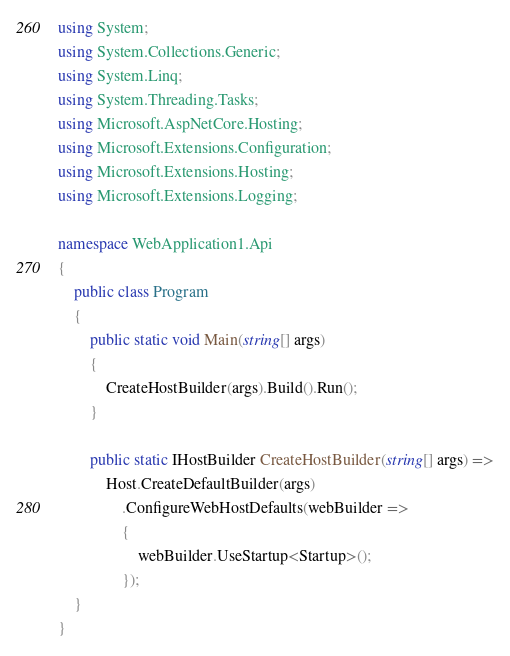Convert code to text. <code><loc_0><loc_0><loc_500><loc_500><_C#_>using System;
using System.Collections.Generic;
using System.Linq;
using System.Threading.Tasks;
using Microsoft.AspNetCore.Hosting;
using Microsoft.Extensions.Configuration;
using Microsoft.Extensions.Hosting;
using Microsoft.Extensions.Logging;

namespace WebApplication1.Api
{
    public class Program
    {
        public static void Main(string[] args)
        {
            CreateHostBuilder(args).Build().Run();
        }

        public static IHostBuilder CreateHostBuilder(string[] args) =>
            Host.CreateDefaultBuilder(args)
                .ConfigureWebHostDefaults(webBuilder =>
                {
                    webBuilder.UseStartup<Startup>();
                });
    }
}
</code> 